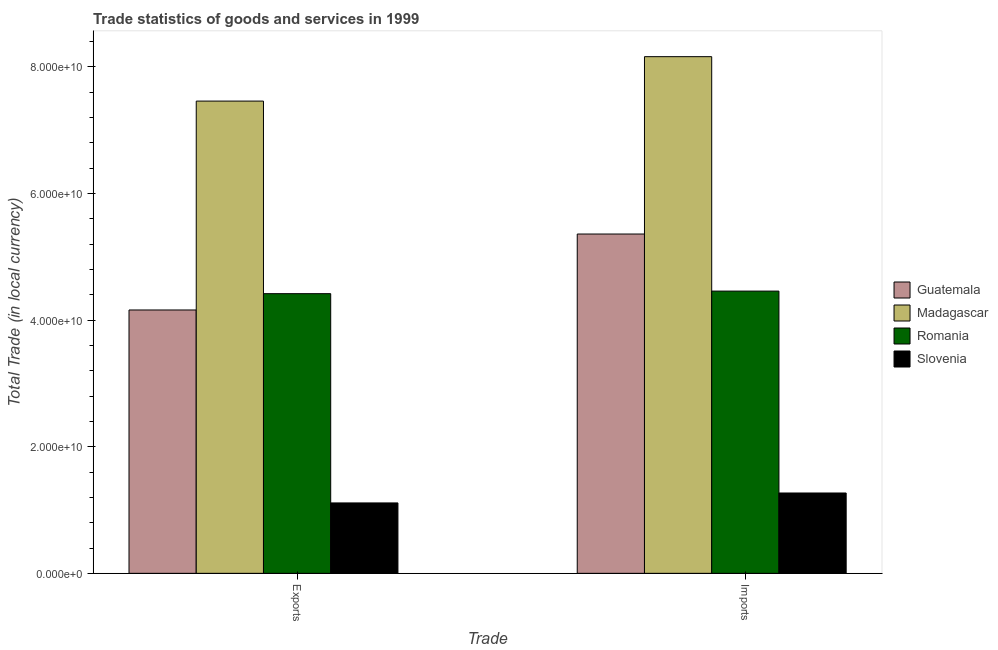How many different coloured bars are there?
Make the answer very short. 4. Are the number of bars per tick equal to the number of legend labels?
Your response must be concise. Yes. How many bars are there on the 1st tick from the left?
Offer a very short reply. 4. How many bars are there on the 2nd tick from the right?
Your answer should be very brief. 4. What is the label of the 2nd group of bars from the left?
Your answer should be compact. Imports. What is the imports of goods and services in Madagascar?
Your response must be concise. 8.16e+1. Across all countries, what is the maximum imports of goods and services?
Your response must be concise. 8.16e+1. Across all countries, what is the minimum imports of goods and services?
Provide a succinct answer. 1.27e+1. In which country was the imports of goods and services maximum?
Provide a short and direct response. Madagascar. In which country was the export of goods and services minimum?
Offer a terse response. Slovenia. What is the total export of goods and services in the graph?
Make the answer very short. 1.71e+11. What is the difference between the imports of goods and services in Slovenia and that in Romania?
Give a very brief answer. -3.19e+1. What is the difference between the export of goods and services in Guatemala and the imports of goods and services in Madagascar?
Provide a short and direct response. -4.00e+1. What is the average imports of goods and services per country?
Ensure brevity in your answer.  4.81e+1. What is the difference between the export of goods and services and imports of goods and services in Madagascar?
Offer a terse response. -7.02e+09. What is the ratio of the export of goods and services in Madagascar to that in Romania?
Your response must be concise. 1.69. What does the 3rd bar from the left in Exports represents?
Your response must be concise. Romania. What does the 3rd bar from the right in Exports represents?
Ensure brevity in your answer.  Madagascar. Are all the bars in the graph horizontal?
Keep it short and to the point. No. Are the values on the major ticks of Y-axis written in scientific E-notation?
Provide a succinct answer. Yes. How many legend labels are there?
Ensure brevity in your answer.  4. How are the legend labels stacked?
Offer a very short reply. Vertical. What is the title of the graph?
Offer a very short reply. Trade statistics of goods and services in 1999. What is the label or title of the X-axis?
Offer a very short reply. Trade. What is the label or title of the Y-axis?
Offer a very short reply. Total Trade (in local currency). What is the Total Trade (in local currency) of Guatemala in Exports?
Make the answer very short. 4.16e+1. What is the Total Trade (in local currency) in Madagascar in Exports?
Give a very brief answer. 7.46e+1. What is the Total Trade (in local currency) of Romania in Exports?
Your response must be concise. 4.42e+1. What is the Total Trade (in local currency) of Slovenia in Exports?
Give a very brief answer. 1.11e+1. What is the Total Trade (in local currency) of Guatemala in Imports?
Provide a succinct answer. 5.36e+1. What is the Total Trade (in local currency) of Madagascar in Imports?
Offer a very short reply. 8.16e+1. What is the Total Trade (in local currency) of Romania in Imports?
Give a very brief answer. 4.46e+1. What is the Total Trade (in local currency) in Slovenia in Imports?
Make the answer very short. 1.27e+1. Across all Trade, what is the maximum Total Trade (in local currency) of Guatemala?
Your response must be concise. 5.36e+1. Across all Trade, what is the maximum Total Trade (in local currency) in Madagascar?
Your response must be concise. 8.16e+1. Across all Trade, what is the maximum Total Trade (in local currency) in Romania?
Your answer should be very brief. 4.46e+1. Across all Trade, what is the maximum Total Trade (in local currency) of Slovenia?
Your answer should be very brief. 1.27e+1. Across all Trade, what is the minimum Total Trade (in local currency) in Guatemala?
Your answer should be compact. 4.16e+1. Across all Trade, what is the minimum Total Trade (in local currency) in Madagascar?
Make the answer very short. 7.46e+1. Across all Trade, what is the minimum Total Trade (in local currency) of Romania?
Give a very brief answer. 4.42e+1. Across all Trade, what is the minimum Total Trade (in local currency) in Slovenia?
Provide a short and direct response. 1.11e+1. What is the total Total Trade (in local currency) of Guatemala in the graph?
Your answer should be very brief. 9.52e+1. What is the total Total Trade (in local currency) in Madagascar in the graph?
Ensure brevity in your answer.  1.56e+11. What is the total Total Trade (in local currency) of Romania in the graph?
Provide a short and direct response. 8.87e+1. What is the total Total Trade (in local currency) of Slovenia in the graph?
Make the answer very short. 2.38e+1. What is the difference between the Total Trade (in local currency) in Guatemala in Exports and that in Imports?
Provide a short and direct response. -1.20e+1. What is the difference between the Total Trade (in local currency) in Madagascar in Exports and that in Imports?
Offer a terse response. -7.02e+09. What is the difference between the Total Trade (in local currency) of Romania in Exports and that in Imports?
Your answer should be compact. -4.04e+08. What is the difference between the Total Trade (in local currency) in Slovenia in Exports and that in Imports?
Offer a terse response. -1.57e+09. What is the difference between the Total Trade (in local currency) in Guatemala in Exports and the Total Trade (in local currency) in Madagascar in Imports?
Your response must be concise. -4.00e+1. What is the difference between the Total Trade (in local currency) of Guatemala in Exports and the Total Trade (in local currency) of Romania in Imports?
Keep it short and to the point. -2.98e+09. What is the difference between the Total Trade (in local currency) of Guatemala in Exports and the Total Trade (in local currency) of Slovenia in Imports?
Your answer should be compact. 2.89e+1. What is the difference between the Total Trade (in local currency) in Madagascar in Exports and the Total Trade (in local currency) in Romania in Imports?
Make the answer very short. 3.00e+1. What is the difference between the Total Trade (in local currency) in Madagascar in Exports and the Total Trade (in local currency) in Slovenia in Imports?
Your answer should be very brief. 6.19e+1. What is the difference between the Total Trade (in local currency) in Romania in Exports and the Total Trade (in local currency) in Slovenia in Imports?
Provide a succinct answer. 3.15e+1. What is the average Total Trade (in local currency) in Guatemala per Trade?
Provide a succinct answer. 4.76e+1. What is the average Total Trade (in local currency) in Madagascar per Trade?
Offer a terse response. 7.81e+1. What is the average Total Trade (in local currency) of Romania per Trade?
Keep it short and to the point. 4.44e+1. What is the average Total Trade (in local currency) in Slovenia per Trade?
Your answer should be very brief. 1.19e+1. What is the difference between the Total Trade (in local currency) of Guatemala and Total Trade (in local currency) of Madagascar in Exports?
Make the answer very short. -3.30e+1. What is the difference between the Total Trade (in local currency) in Guatemala and Total Trade (in local currency) in Romania in Exports?
Keep it short and to the point. -2.58e+09. What is the difference between the Total Trade (in local currency) of Guatemala and Total Trade (in local currency) of Slovenia in Exports?
Keep it short and to the point. 3.05e+1. What is the difference between the Total Trade (in local currency) of Madagascar and Total Trade (in local currency) of Romania in Exports?
Your response must be concise. 3.04e+1. What is the difference between the Total Trade (in local currency) of Madagascar and Total Trade (in local currency) of Slovenia in Exports?
Provide a succinct answer. 6.35e+1. What is the difference between the Total Trade (in local currency) in Romania and Total Trade (in local currency) in Slovenia in Exports?
Make the answer very short. 3.31e+1. What is the difference between the Total Trade (in local currency) of Guatemala and Total Trade (in local currency) of Madagascar in Imports?
Keep it short and to the point. -2.80e+1. What is the difference between the Total Trade (in local currency) in Guatemala and Total Trade (in local currency) in Romania in Imports?
Your answer should be compact. 9.01e+09. What is the difference between the Total Trade (in local currency) of Guatemala and Total Trade (in local currency) of Slovenia in Imports?
Your answer should be compact. 4.09e+1. What is the difference between the Total Trade (in local currency) in Madagascar and Total Trade (in local currency) in Romania in Imports?
Give a very brief answer. 3.70e+1. What is the difference between the Total Trade (in local currency) in Madagascar and Total Trade (in local currency) in Slovenia in Imports?
Ensure brevity in your answer.  6.89e+1. What is the difference between the Total Trade (in local currency) in Romania and Total Trade (in local currency) in Slovenia in Imports?
Ensure brevity in your answer.  3.19e+1. What is the ratio of the Total Trade (in local currency) of Guatemala in Exports to that in Imports?
Give a very brief answer. 0.78. What is the ratio of the Total Trade (in local currency) of Madagascar in Exports to that in Imports?
Keep it short and to the point. 0.91. What is the ratio of the Total Trade (in local currency) in Romania in Exports to that in Imports?
Provide a short and direct response. 0.99. What is the ratio of the Total Trade (in local currency) in Slovenia in Exports to that in Imports?
Your answer should be compact. 0.88. What is the difference between the highest and the second highest Total Trade (in local currency) in Guatemala?
Your response must be concise. 1.20e+1. What is the difference between the highest and the second highest Total Trade (in local currency) of Madagascar?
Make the answer very short. 7.02e+09. What is the difference between the highest and the second highest Total Trade (in local currency) in Romania?
Make the answer very short. 4.04e+08. What is the difference between the highest and the second highest Total Trade (in local currency) of Slovenia?
Keep it short and to the point. 1.57e+09. What is the difference between the highest and the lowest Total Trade (in local currency) in Guatemala?
Provide a succinct answer. 1.20e+1. What is the difference between the highest and the lowest Total Trade (in local currency) in Madagascar?
Give a very brief answer. 7.02e+09. What is the difference between the highest and the lowest Total Trade (in local currency) of Romania?
Keep it short and to the point. 4.04e+08. What is the difference between the highest and the lowest Total Trade (in local currency) in Slovenia?
Provide a succinct answer. 1.57e+09. 